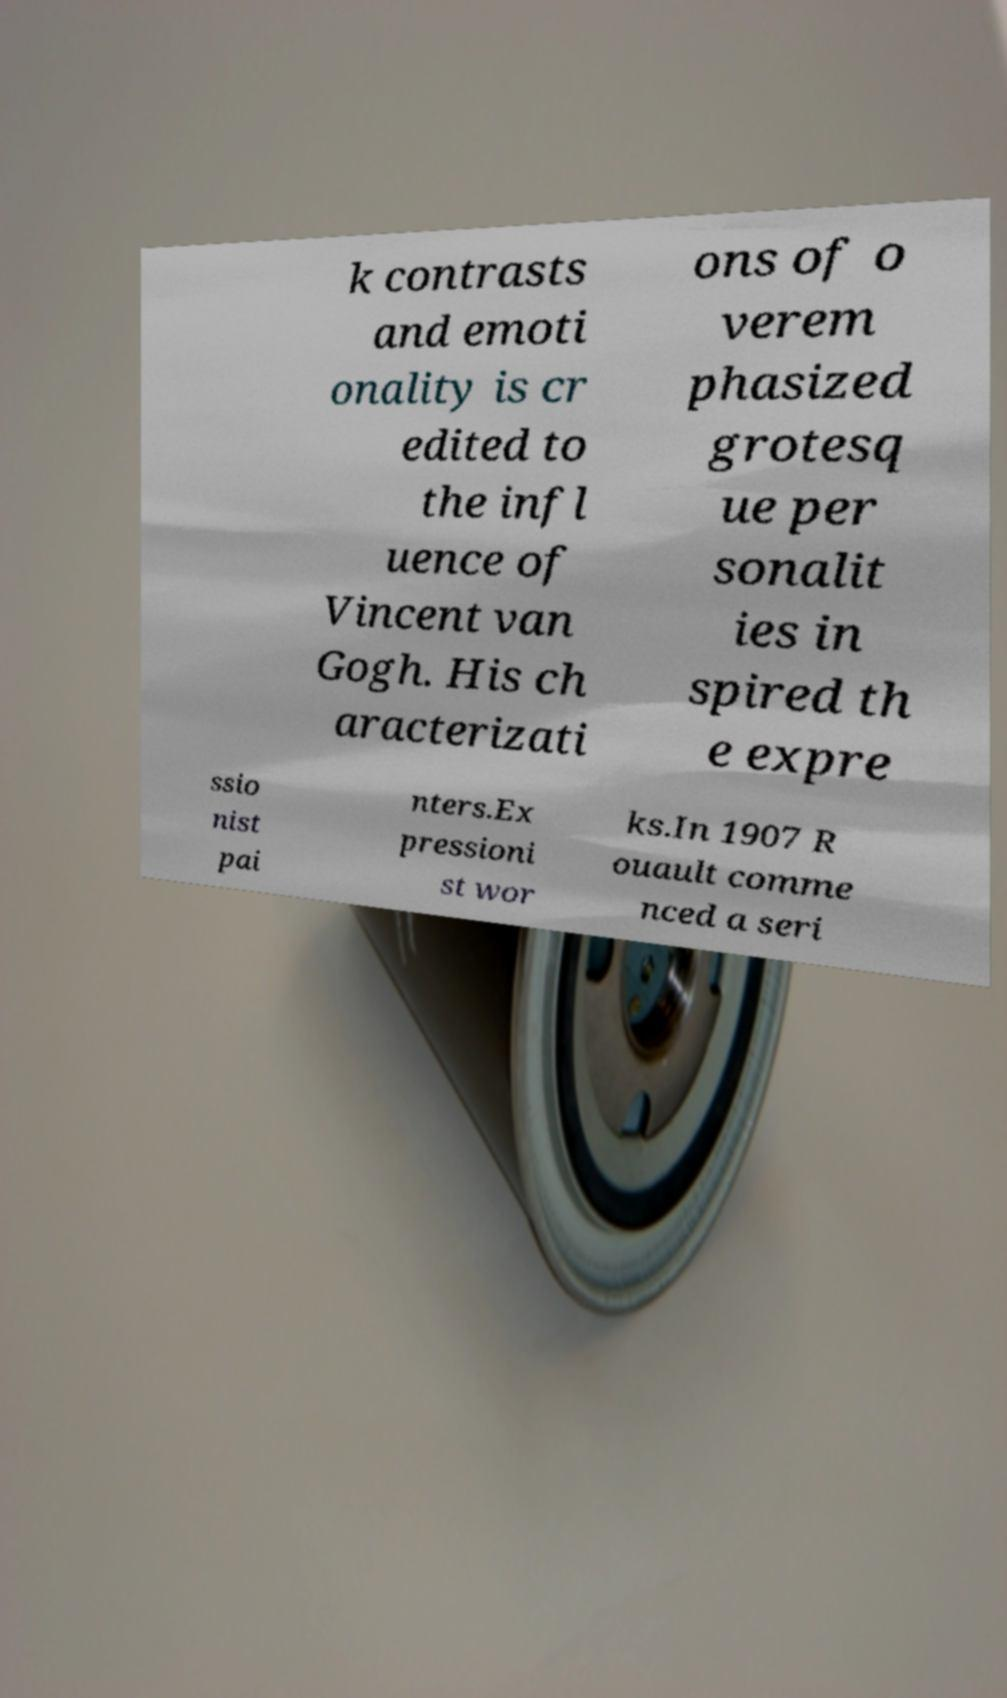I need the written content from this picture converted into text. Can you do that? k contrasts and emoti onality is cr edited to the infl uence of Vincent van Gogh. His ch aracterizati ons of o verem phasized grotesq ue per sonalit ies in spired th e expre ssio nist pai nters.Ex pressioni st wor ks.In 1907 R ouault comme nced a seri 